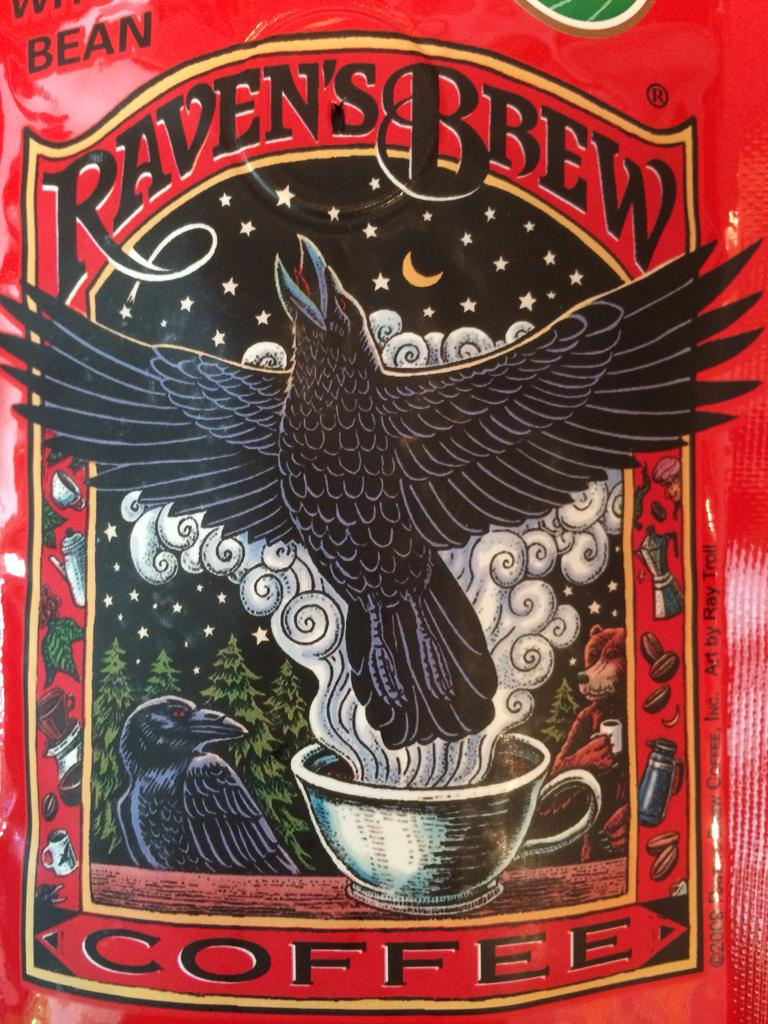What is the main subject of the image? The main subject of the image is a coffee packet. Can you describe the coffee packet in the image? The coffee packet is the primary focus of the image. What song is playing in the background of the image? There is no song playing in the background of the image, as it only features a coffee packet. Is there any eggnog present in the image? There is no eggnog present in the image; it only features a coffee packet. 